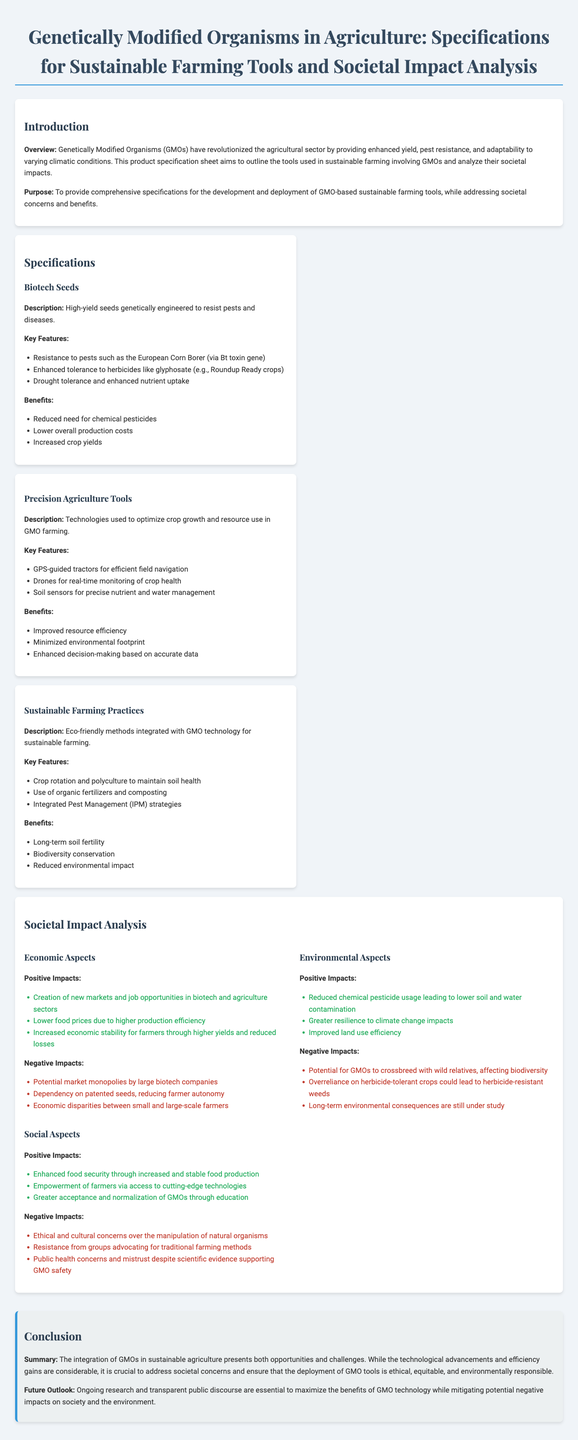What are the key features of biotech seeds? Key features are listed under "Biotech Seeds" in the specifications section.
Answer: Resistance to pests, enhanced tolerance to herbicides, drought tolerance What is a benefit of precision agriculture tools? Benefits are outlined in the precision agriculture tools section.
Answer: Improved resource efficiency What societal aspect discusses public health concerns? The societal aspect refers to public health concerns in the "Social Aspects" section.
Answer: Social Aspects What does the introduction highlight about GMOs? The introduction section discusses the overall impact of GMOs.
Answer: Revolutionized the agricultural sector How many positive impacts are listed under Economic Aspects? The number of positive impacts can be found in the Economic Aspects section.
Answer: Three What is one negative impact identified in Environmental Aspects? Negative impacts are specified in the Environmental Aspects section.
Answer: Potential for GMOs to crossbreed with wild relatives What sustainable farming practice is mentioned in the specifications? The sustainable farming practices section provides examples of eco-friendly methods.
Answer: Crop rotation What is the summary of the conclusion? The conclusion section provides a summary of the document's findings.
Answer: Opportunities and challenges What technology is used for real-time monitoring in precision agriculture? Technologies used for monitoring are specified in the precision agriculture tools section.
Answer: Drones 